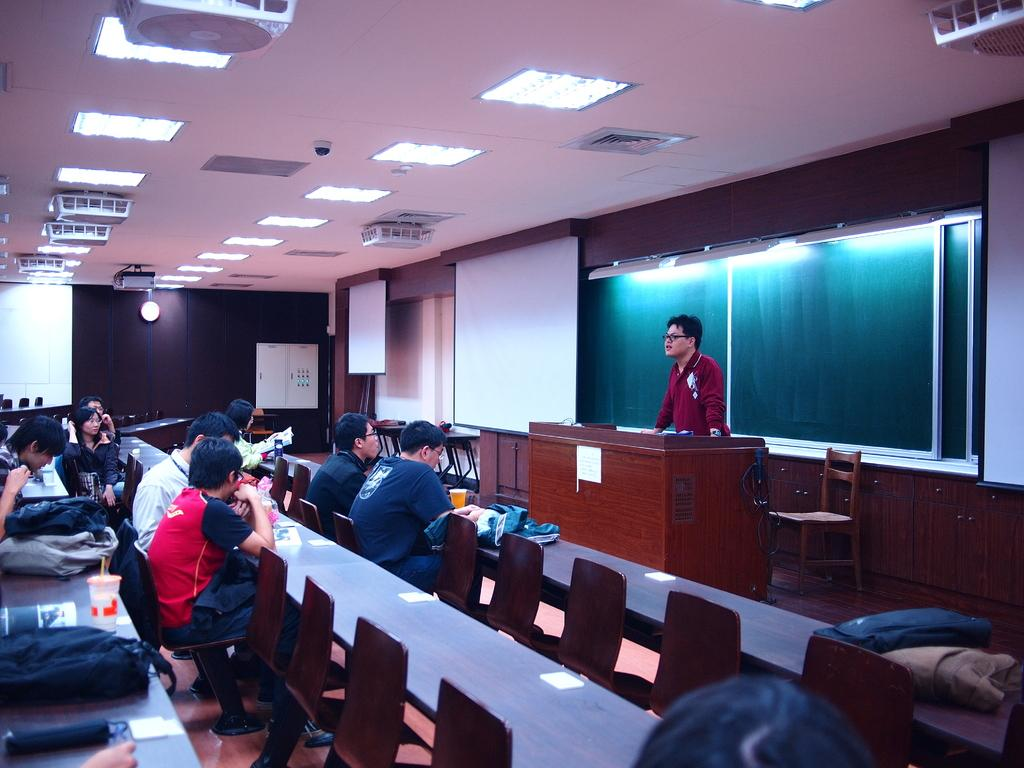What is the general arrangement of people in the image? There is a group of people seated in the image. What is the man in the image doing? There is a man standing and speaking in the image. What is the purpose of the projector screen in the image? The projector screen is likely used for presentations or visual aids. What type of lighting is present in the image? There are roof lights visible in the image. What type of mouth does the sun have in the image? The sun does not have a mouth, as it is a celestial body and not a living being. 